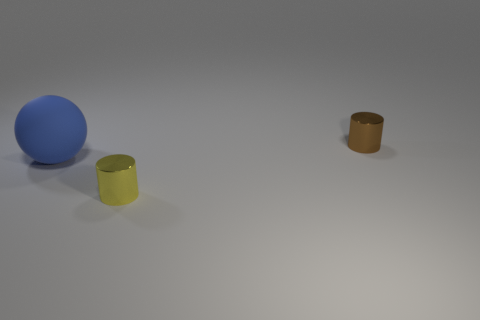Are there any other things that are the same size as the blue thing?
Make the answer very short. No. What is the tiny yellow object made of?
Keep it short and to the point. Metal. Do the large thing that is left of the tiny brown cylinder and the small thing that is in front of the brown metallic object have the same material?
Offer a terse response. No. Is there any other thing that is the same color as the ball?
Give a very brief answer. No. What is the color of the other shiny thing that is the same shape as the small yellow metallic object?
Provide a succinct answer. Brown. What is the size of the thing that is both on the right side of the large sphere and in front of the brown metallic cylinder?
Offer a very short reply. Small. Do the thing behind the large thing and the yellow shiny object in front of the large blue ball have the same shape?
Provide a succinct answer. Yes. What number of tiny cylinders have the same material as the large sphere?
Your response must be concise. 0. What is the shape of the object that is both behind the yellow object and on the right side of the ball?
Keep it short and to the point. Cylinder. Is the cylinder behind the large blue sphere made of the same material as the blue object?
Ensure brevity in your answer.  No. 